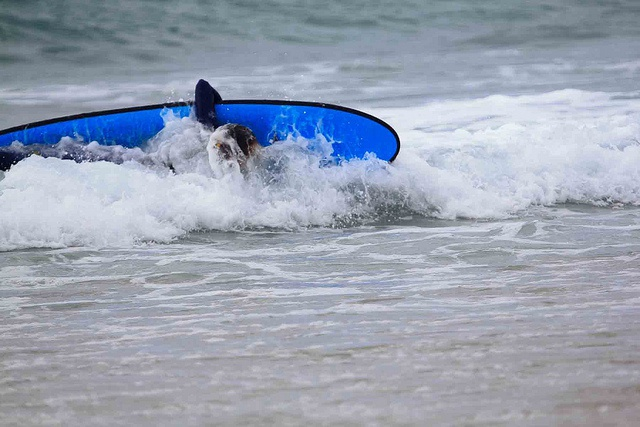Describe the objects in this image and their specific colors. I can see surfboard in purple, blue, black, and darkblue tones and people in purple, black, darkgray, gray, and navy tones in this image. 